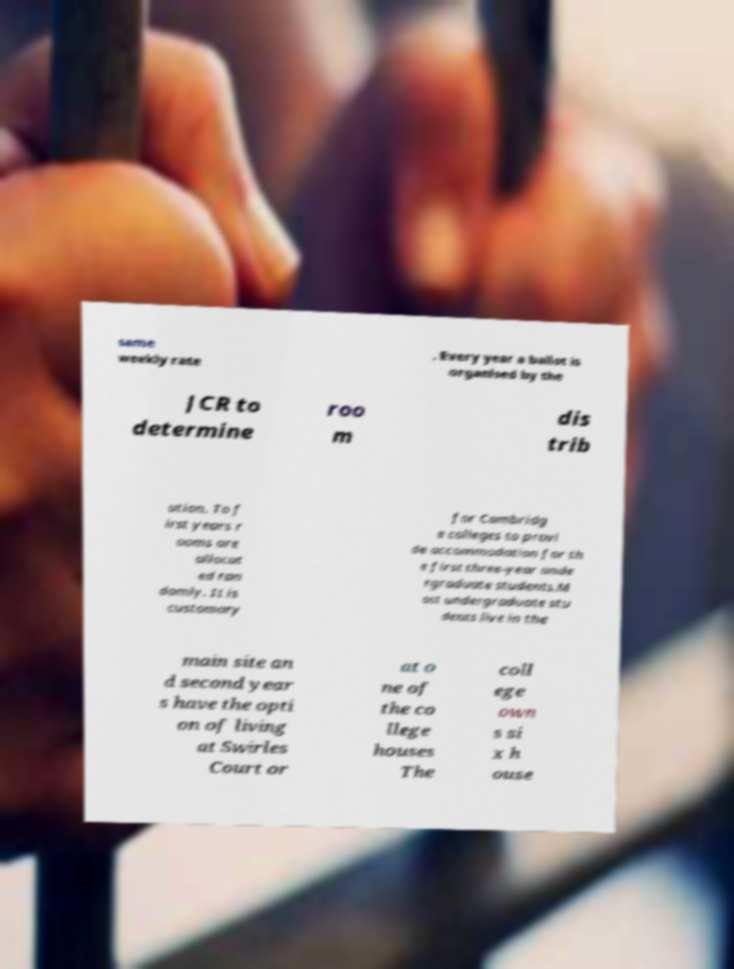Could you extract and type out the text from this image? same weekly rate . Every year a ballot is organised by the JCR to determine roo m dis trib ution. To f irst years r ooms are allocat ed ran domly. It is customary for Cambridg e colleges to provi de accommodation for th e first three-year unde rgraduate students.M ost undergraduate stu dents live in the main site an d second year s have the opti on of living at Swirles Court or at o ne of the co llege houses The coll ege own s si x h ouse 